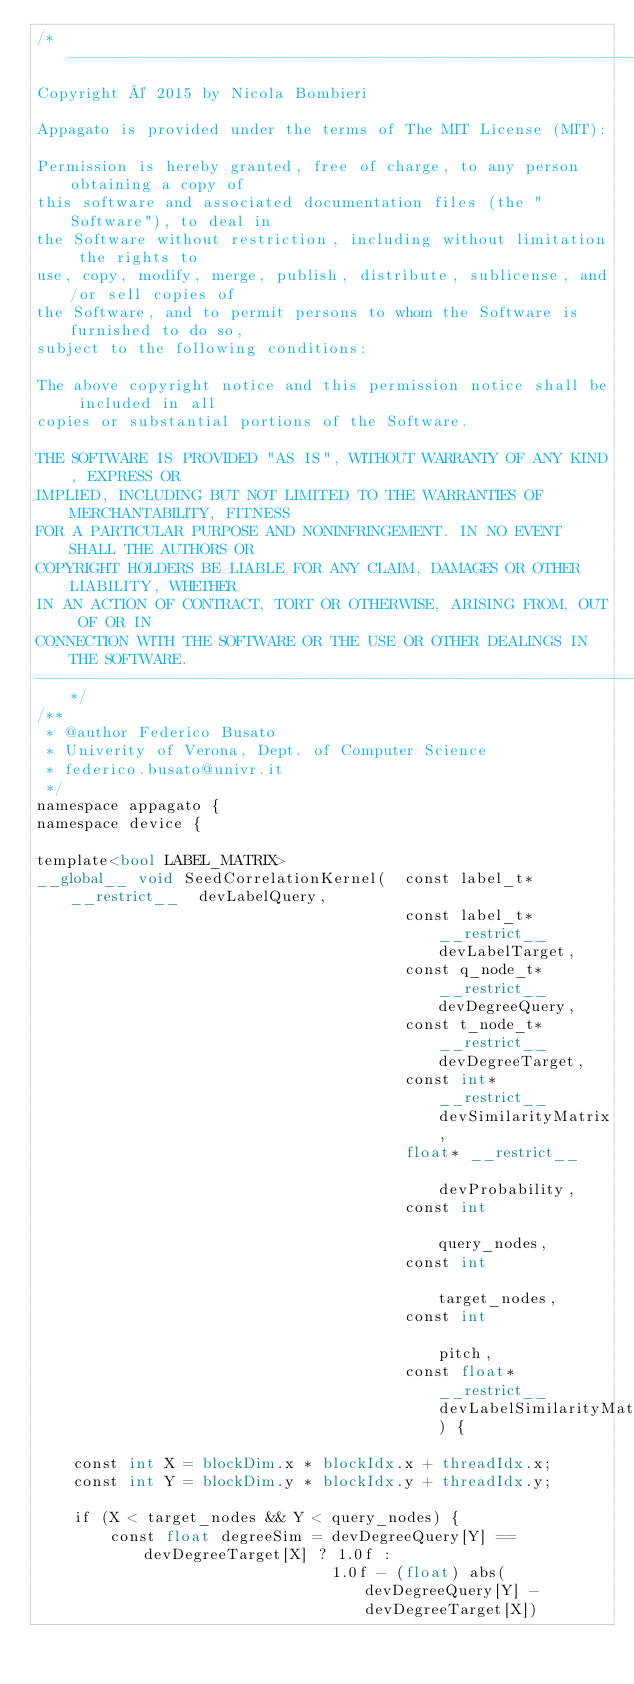Convert code to text. <code><loc_0><loc_0><loc_500><loc_500><_Cuda_>/*------------------------------------------------------------------------------
Copyright © 2015 by Nicola Bombieri

Appagato is provided under the terms of The MIT License (MIT):

Permission is hereby granted, free of charge, to any person obtaining a copy of
this software and associated documentation files (the "Software"), to deal in
the Software without restriction, including without limitation the rights to
use, copy, modify, merge, publish, distribute, sublicense, and/or sell copies of
the Software, and to permit persons to whom the Software is furnished to do so,
subject to the following conditions:

The above copyright notice and this permission notice shall be included in all
copies or substantial portions of the Software.

THE SOFTWARE IS PROVIDED "AS IS", WITHOUT WARRANTY OF ANY KIND, EXPRESS OR
IMPLIED, INCLUDING BUT NOT LIMITED TO THE WARRANTIES OF MERCHANTABILITY, FITNESS
FOR A PARTICULAR PURPOSE AND NONINFRINGEMENT. IN NO EVENT SHALL THE AUTHORS OR
COPYRIGHT HOLDERS BE LIABLE FOR ANY CLAIM, DAMAGES OR OTHER LIABILITY, WHETHER
IN AN ACTION OF CONTRACT, TORT OR OTHERWISE, ARISING FROM, OUT OF OR IN
CONNECTION WITH THE SOFTWARE OR THE USE OR OTHER DEALINGS IN THE SOFTWARE.
------------------------------------------------------------------------------*/
/**
 * @author Federico Busato
 * Univerity of Verona, Dept. of Computer Science
 * federico.busato@univr.it
 */
namespace appagato {
namespace device {

template<bool LABEL_MATRIX>
__global__ void SeedCorrelationKernel(	const label_t* __restrict__  devLabelQuery,
										const label_t* __restrict__  devLabelTarget,
										const q_node_t* __restrict__ devDegreeQuery,
										const t_node_t* __restrict__ devDegreeTarget,
										const int* __restrict__      devSimilarityMatrix,
										float* __restrict__          devProbability,
										const int                    query_nodes,
										const int                    target_nodes,
										const int                    pitch,
                                        const float* __restrict__    devLabelSimilarityMatrix) {

	const int X = blockDim.x * blockIdx.x + threadIdx.x;
	const int Y = blockDim.y * blockIdx.y + threadIdx.y;

	if (X < target_nodes && Y < query_nodes) {
		const float degreeSim = devDegreeQuery[Y] == devDegreeTarget[X] ? 1.0f :
								1.0f - (float) abs(devDegreeQuery[Y] - devDegreeTarget[X])</code> 